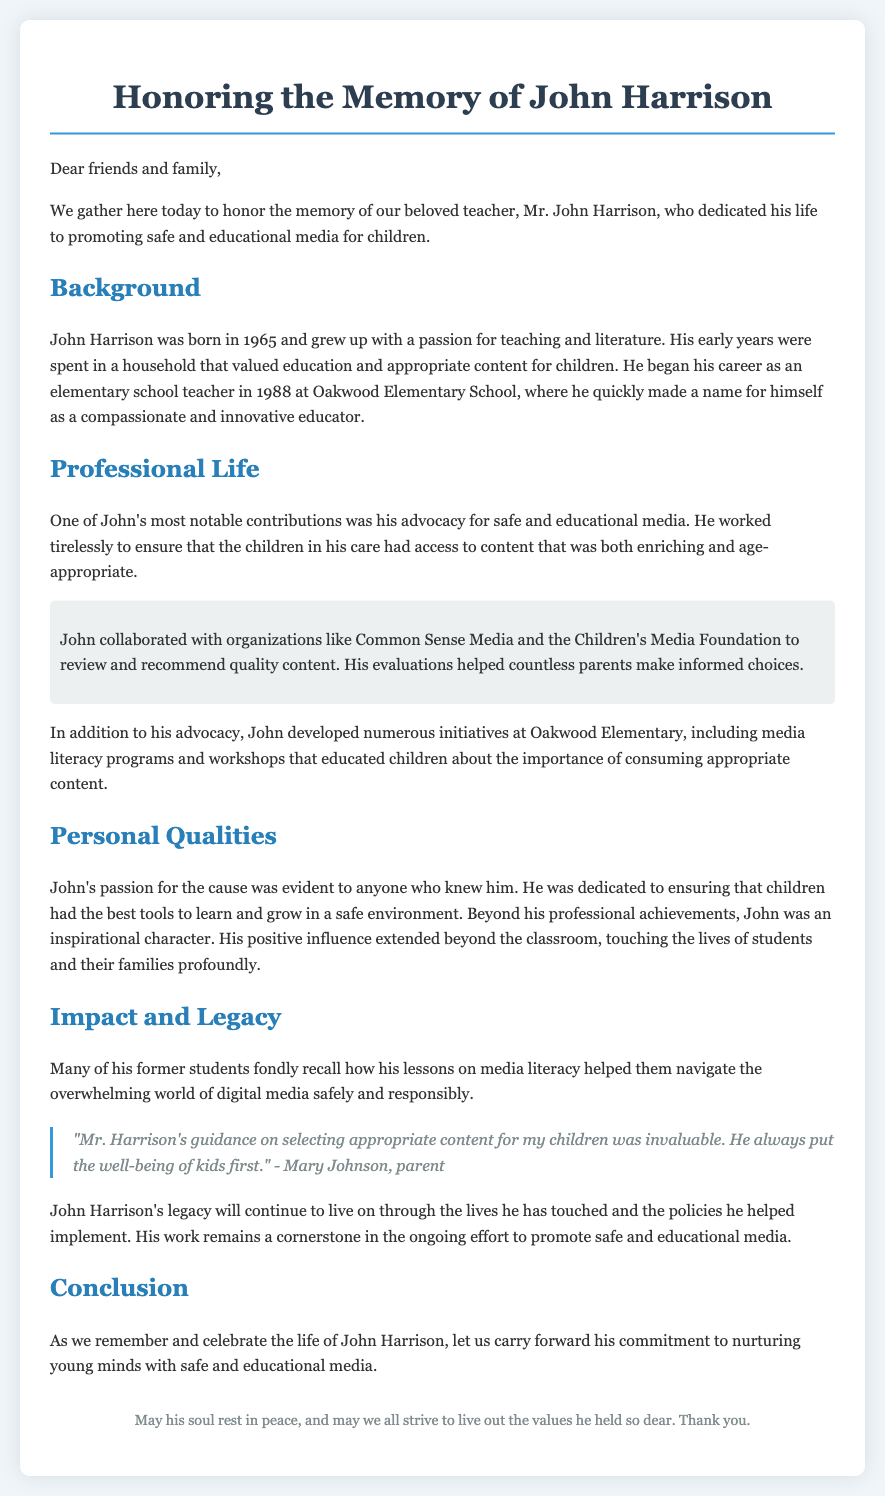What year was John Harrison born? The document states that John Harrison was born in 1965.
Answer: 1965 What school did John Harrison teach at? The document mentions that he began his career at Oakwood Elementary School.
Answer: Oakwood Elementary School Which organization did John collaborate with for media evaluation? The document refers to John collaborating with Common Sense Media.
Answer: Common Sense Media What was one initiative developed by John at Oakwood Elementary? The document lists media literacy programs as one of the initiatives developed by John.
Answer: Media literacy programs Who provided a quote about Mr. Harrison's guidance? The document includes a quote from Mary Johnson, a parent.
Answer: Mary Johnson What was John's primary focus throughout his career? The document highlights that John's main focus was promoting safe and educational media for children.
Answer: Promoting safe and educational media What is the overarching message in the conclusion? The conclusion emphasizes the importance of carrying forward John's commitment to nurturing young minds.
Answer: Nurturing young minds What type of content did John advocate for? The document states that John advocated for content that was both enriching and age-appropriate.
Answer: Enriching and age-appropriate content 